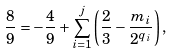Convert formula to latex. <formula><loc_0><loc_0><loc_500><loc_500>\frac { 8 } { 9 } = - \frac { 4 } { 9 } + \sum _ { i = 1 } ^ { j } \left ( \frac { 2 } { 3 } - \frac { m _ { i } } { 2 ^ { q _ { i } } } \right ) ,</formula> 